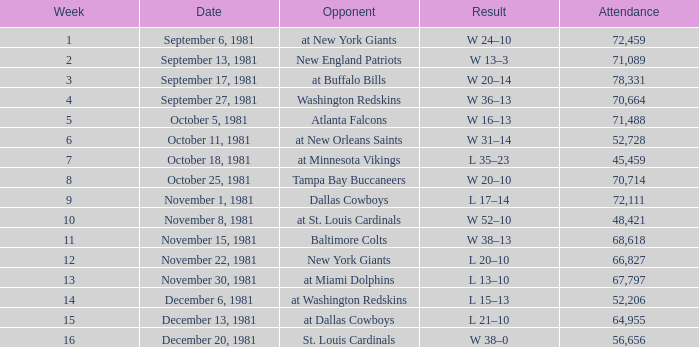What is the presence, when the adversary is the tampa bay buccaneers? 70714.0. 